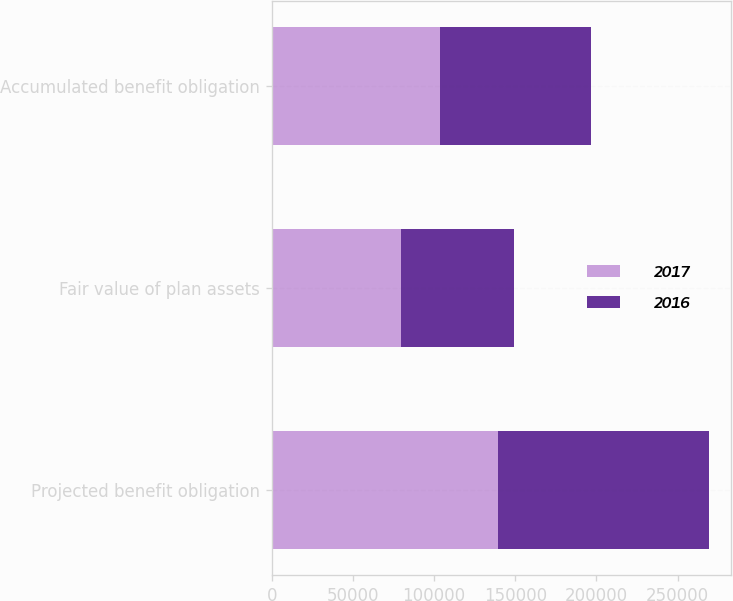<chart> <loc_0><loc_0><loc_500><loc_500><stacked_bar_chart><ecel><fcel>Projected benefit obligation<fcel>Fair value of plan assets<fcel>Accumulated benefit obligation<nl><fcel>2017<fcel>139516<fcel>79616<fcel>103470<nl><fcel>2016<fcel>129711<fcel>69823<fcel>93164<nl></chart> 